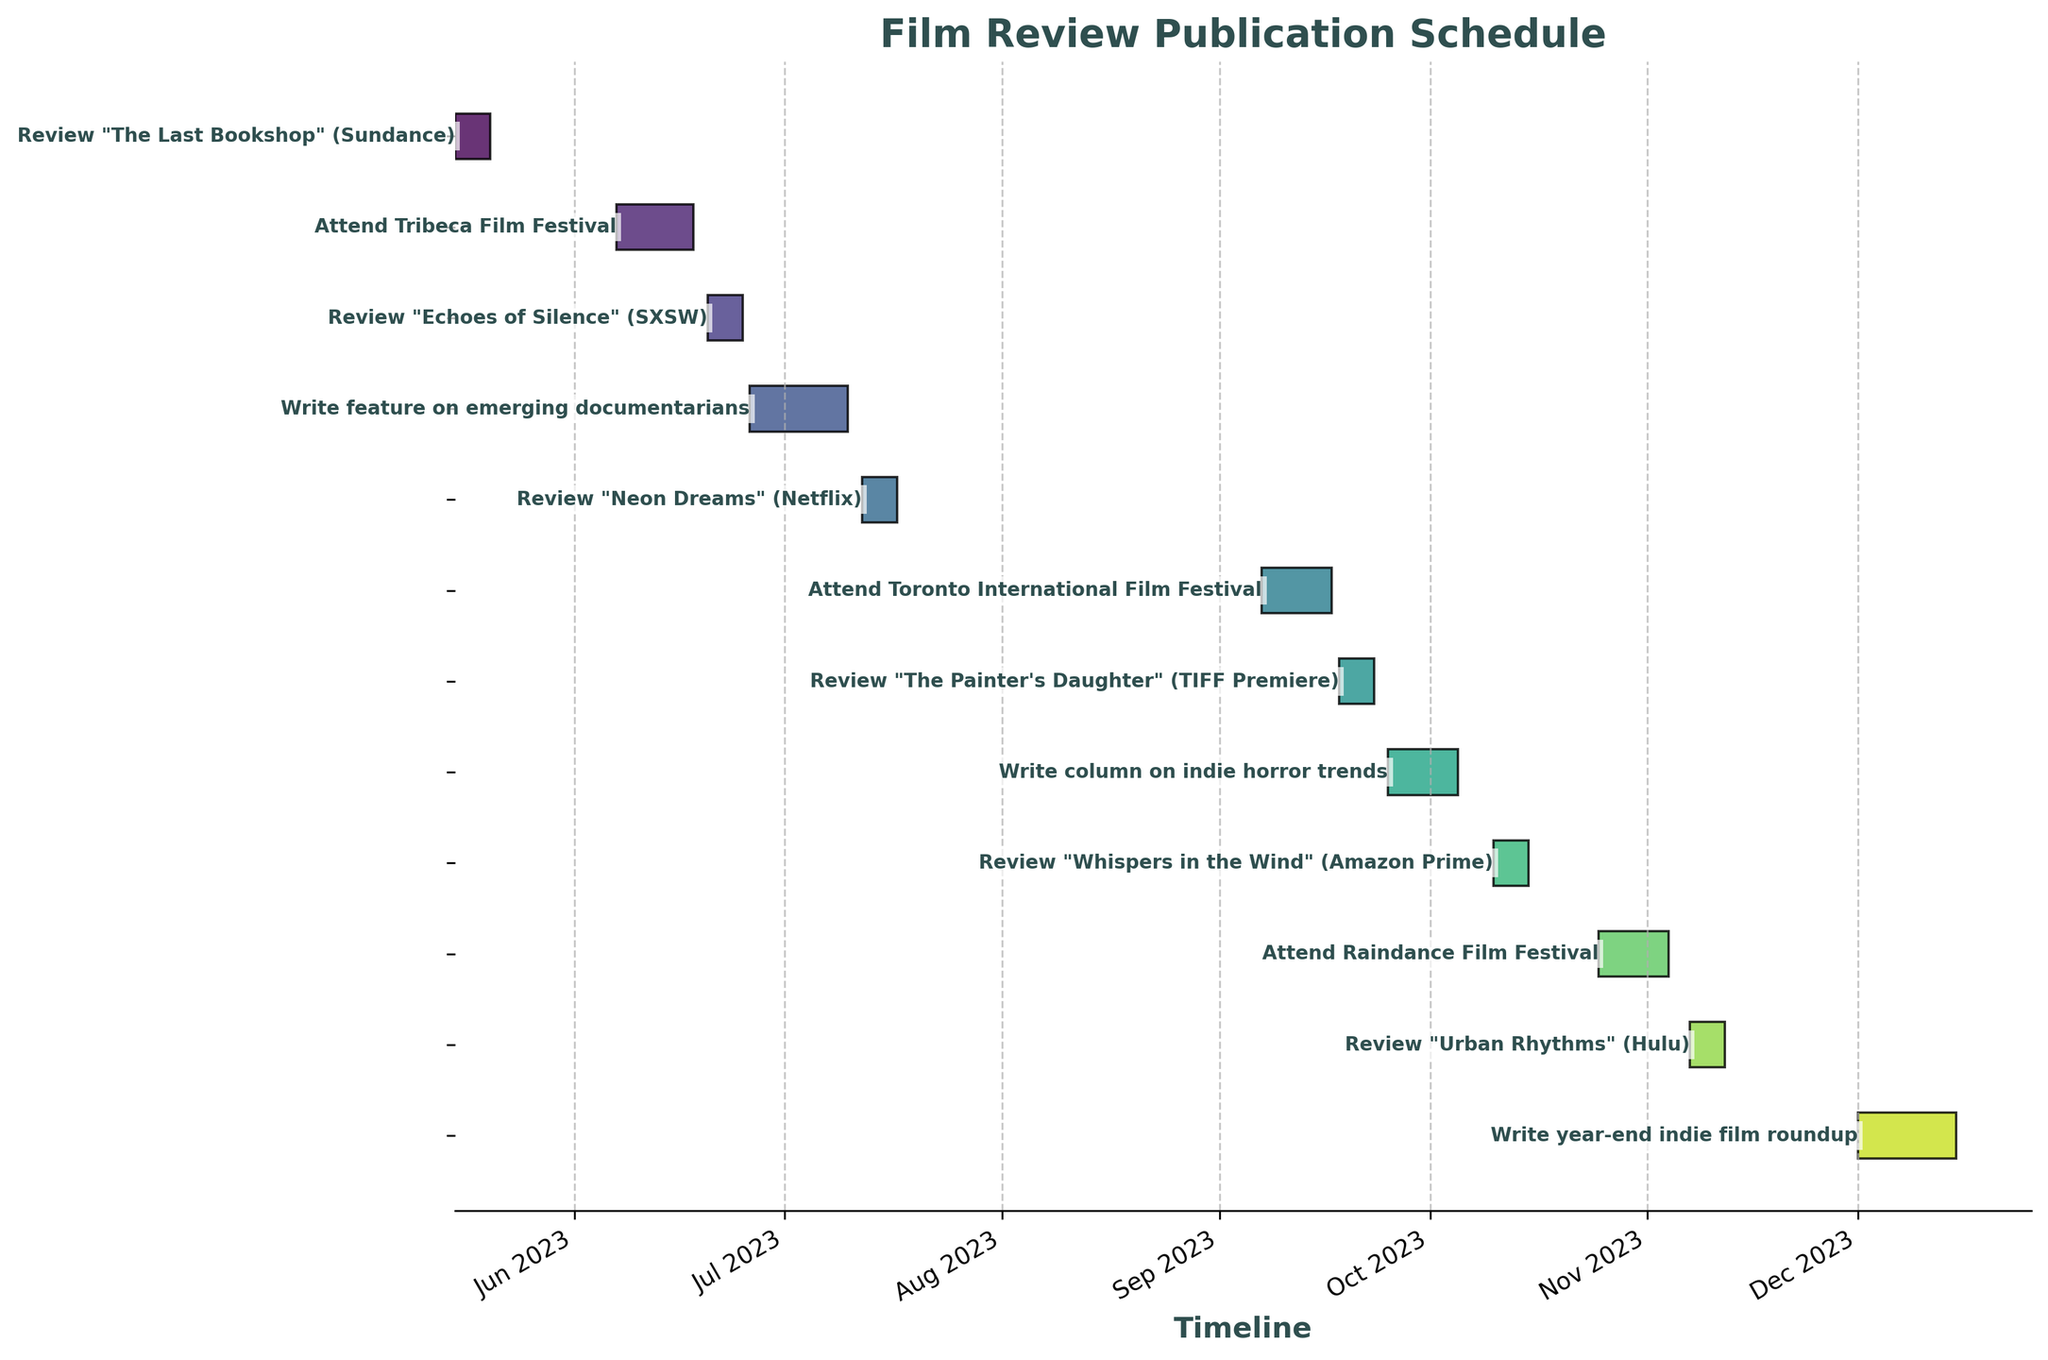What is the title of the figure? The title of the figure is usually displayed at the top of the chart. In this case, it is "Film Review Publication Schedule."
Answer: Film Review Publication Schedule What is the range of the timeline shown in the figure? To determine the timeline range, look at the x-axis. The earliest date is May 2023 and the latest date is December 2023.
Answer: May 2023 to December 2023 How many tasks are shown in the Gantt Chart? Count the number of horizontal bars in the chart. There are 12 tasks listed.
Answer: 12 Which task has the longest duration? Compare the length of all horizontal bars to find the longest one. The task "Write feature on emerging documentarians" has the longest duration from June 26 to July 10.
Answer: Write feature on emerging documentarians What is the duration of the "Write year-end indie film roundup" task? Calculate the difference between the end date (2023-12-15) and the start date (2023-12-01).
Answer: 15 days Which two tasks are scheduled closest to each other? Find tasks with start and end dates that are closest. "Review 'Urban Rhythms' (Hulu)" ends on 2023-11-12, and "Write year-end indie film roundup" starts on 2023-12-01, so they are the closest.
Answer: Review "Urban Rhythms" (Hulu) and Write year-end indie film roundup Which task immediately follows "Attend Toronto International Film Festival"? Identify the end date of "Attend Toronto International Film Festival" (2023-09-17), and the task starting immediately after is "Review 'The Painter's Daughter' (TIFF Premiere)" starting on 2023-09-18.
Answer: Review "The Painter's Daughter" (TIFF Premiere) How many tasks involve writing a review for a specific film? Count the tasks that mention "Review" in their description. There are 6 such tasks.
Answer: 6 What is the average duration of all tasks in the figure? First, calculate the duration of each task in days, sum them up, and divide by the number of tasks. Total duration is 130 days divided by 12 tasks, which equals approximately 10.83 days.
Answer: 10.83 days 